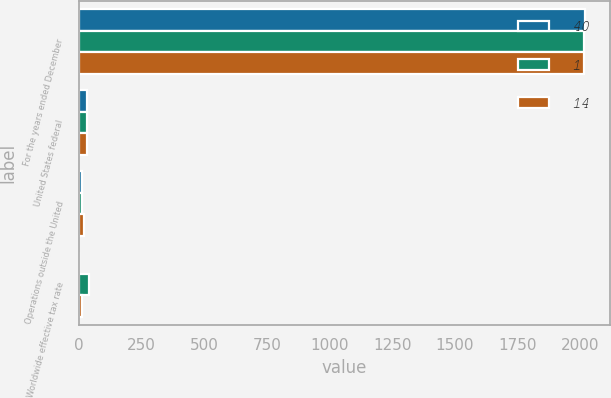Convert chart. <chart><loc_0><loc_0><loc_500><loc_500><stacked_bar_chart><ecel><fcel>For the years ended December<fcel>United States federal<fcel>Operations outside the United<fcel>Worldwide effective tax rate<nl><fcel>40<fcel>2017<fcel>35<fcel>12<fcel>1<nl><fcel>1<fcel>2016<fcel>35<fcel>14<fcel>40<nl><fcel>14<fcel>2015<fcel>35<fcel>21<fcel>14<nl></chart> 